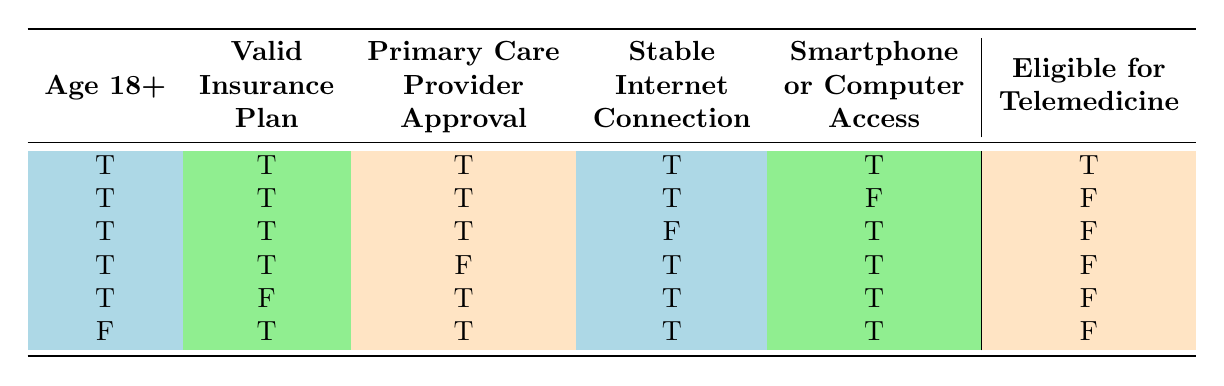What percentage of participants aged 18 and older are eligible for telemedicine? In the table, there are 6 cases in total, and 1 case shows ineligible individuals while 5 cases show eligible individuals. The eligible participants are all those rows where "Eligible for Telemedicine" is true, resulting in 1 out of 6 cases. Therefore, the percentage of eligible participants is (1/6) * 100 = 16.67%.
Answer: 16.67% How many conditions must be met for an individual to be eligible for telemedicine? Based on the table, all five variables: Age 18+, Valid Insurance Plan, Primary Care Provider Approval, Stable Internet Connection, and Smartphone or Computer Access must be true for eligibility. If any one of these is false, the eligibility status defaults to false.
Answer: 5 Is a valid insurance plan necessary for telemedicine eligibility? By reviewing the table, whenever the "Valid Insurance Plan" is false, the "Eligible for Telemedicine" is also false in all instances. Thus, a valid insurance plan is indeed required for telemedicine eligibility.
Answer: Yes What are the eligibility outcomes for a person aged 18 or older without a smartphone or computer access but with a valid insurance plan and primary care provider approval? Referring to the row that describes these conditions: Age 18+ is true, Valid Insurance Plan is true, Primary Care Provider Approval is true, but Stable Internet Connection is false and access is false. In this case, the outcome is ineligible for telemedicine, showing that a lack of access results in ineligibility.
Answer: Ineligible Among those with a stable internet connection and smartphone access, how many are eligible for telemedicine? The two relevant rows have the criteria for eligibility based on having both "Stable Internet Connection" and "Smartphone or Computer Access". Reviewing both rows with that access indicates that there are 4 cases. Out of those, only 1 case (where all conditions are true) indicates eligibility. Hence, out of 4, only 1 is eligible.
Answer: 1 What would be the outcome for an individual aged under 18 with all necessary approvals and connections? The table shows that for anyone under 18, regardless of the other conditions being true, the "Eligible for Telemedicine" status is always false. Hence, age under 18 is an automatic disqualification for eligibility.
Answer: Ineligible 